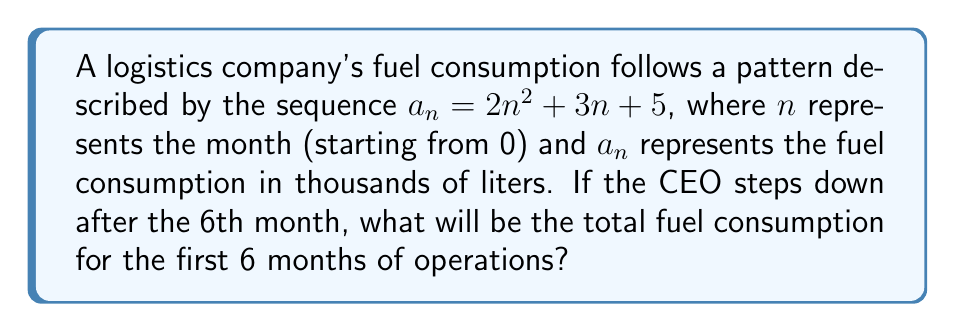Solve this math problem. To solve this problem, we need to calculate the sum of the fuel consumption for the first 6 months (n = 0 to 5).

1. Let's calculate the fuel consumption for each month:

   Month 0 (n = 0): $a_0 = 2(0)^2 + 3(0) + 5 = 5$
   Month 1 (n = 1): $a_1 = 2(1)^2 + 3(1) + 5 = 10$
   Month 2 (n = 2): $a_2 = 2(2)^2 + 3(2) + 5 = 19$
   Month 3 (n = 3): $a_3 = 2(3)^2 + 3(3) + 5 = 32$
   Month 4 (n = 4): $a_4 = 2(4)^2 + 3(4) + 5 = 49$
   Month 5 (n = 5): $a_5 = 2(5)^2 + 3(5) + 5 = 70$

2. Now, we sum up these values:

   $\sum_{n=0}^5 a_n = 5 + 10 + 19 + 32 + 49 + 70 = 185$

3. Therefore, the total fuel consumption for the first 6 months is 185 thousand liters.
Answer: 185 thousand liters 